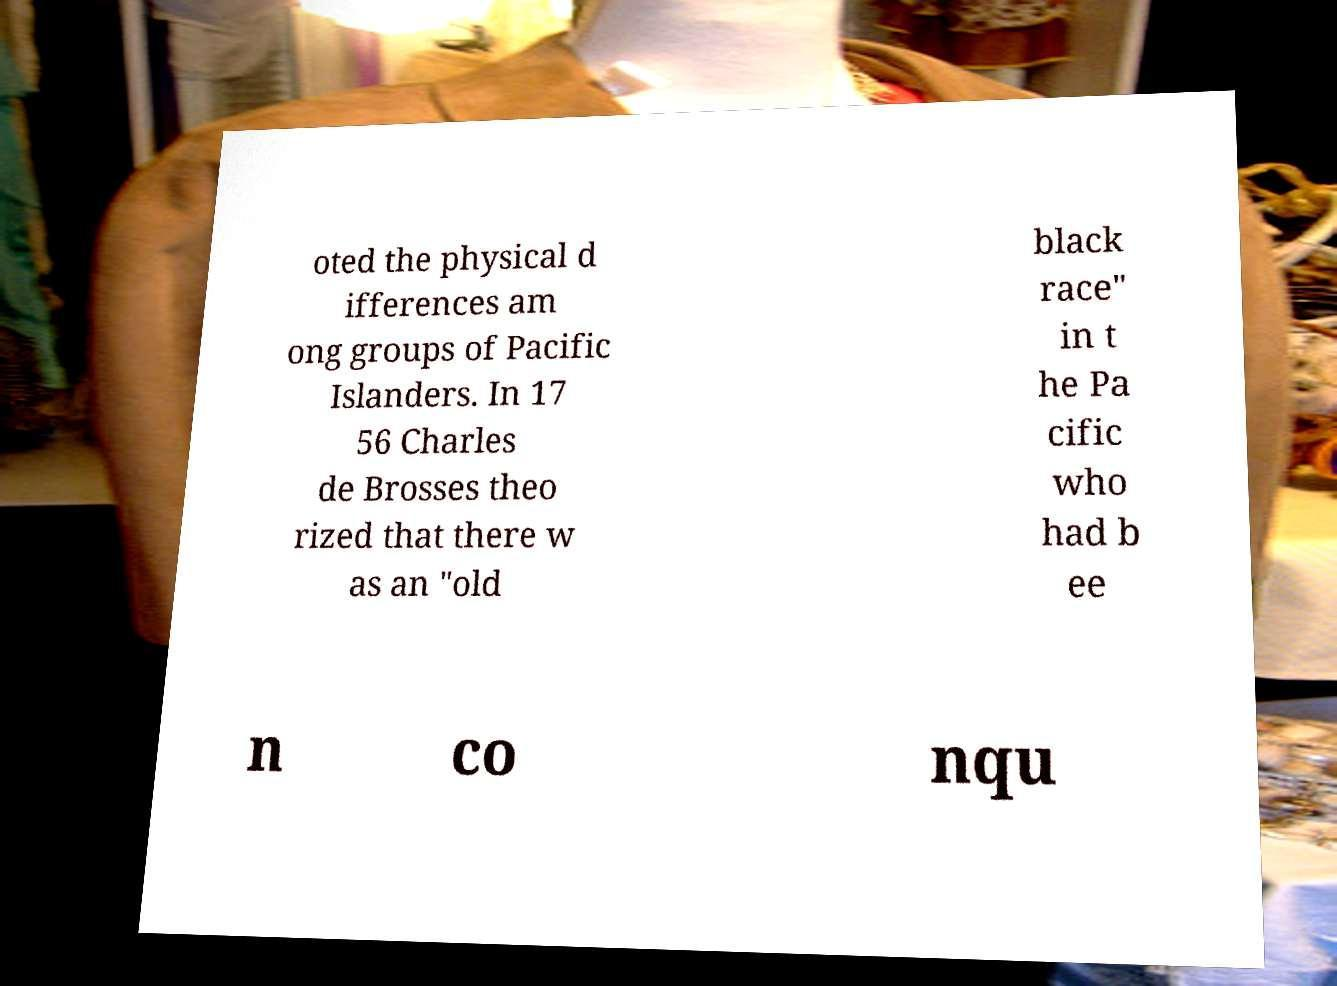There's text embedded in this image that I need extracted. Can you transcribe it verbatim? oted the physical d ifferences am ong groups of Pacific Islanders. In 17 56 Charles de Brosses theo rized that there w as an "old black race" in t he Pa cific who had b ee n co nqu 